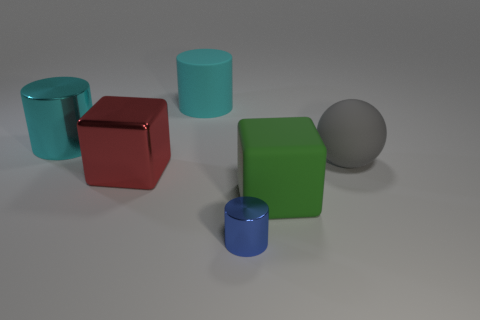Does the shiny thing in front of the large red block have the same shape as the thing to the right of the green rubber cube?
Give a very brief answer. No. The gray object is what size?
Ensure brevity in your answer.  Large. There is a cylinder in front of the big metal object that is in front of the big thing that is to the right of the big rubber cube; what is its material?
Ensure brevity in your answer.  Metal. What number of other objects are there of the same color as the matte cylinder?
Provide a short and direct response. 1. What number of blue things are cylinders or rubber balls?
Offer a very short reply. 1. What is the cylinder in front of the big green cube made of?
Keep it short and to the point. Metal. Is the cyan object behind the cyan shiny cylinder made of the same material as the gray thing?
Keep it short and to the point. Yes. What shape is the tiny metal object?
Keep it short and to the point. Cylinder. There is a cylinder that is left of the cyan cylinder to the right of the shiny cube; what number of shiny blocks are left of it?
Keep it short and to the point. 0. How many other things are there of the same material as the sphere?
Your answer should be compact. 2. 